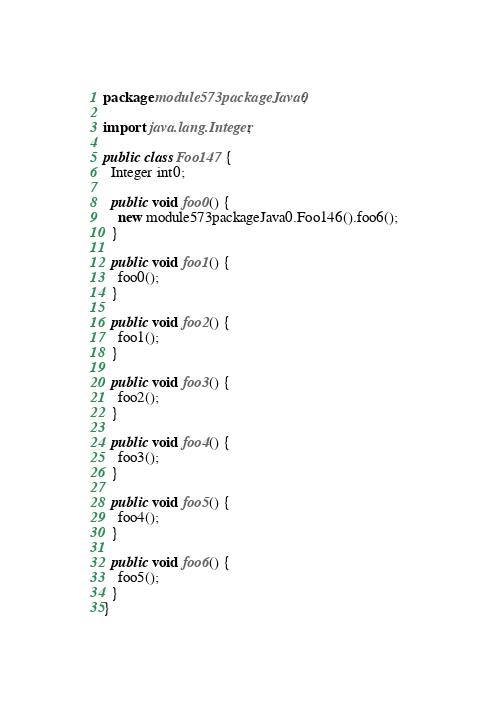Convert code to text. <code><loc_0><loc_0><loc_500><loc_500><_Java_>package module573packageJava0;

import java.lang.Integer;

public class Foo147 {
  Integer int0;

  public void foo0() {
    new module573packageJava0.Foo146().foo6();
  }

  public void foo1() {
    foo0();
  }

  public void foo2() {
    foo1();
  }

  public void foo3() {
    foo2();
  }

  public void foo4() {
    foo3();
  }

  public void foo5() {
    foo4();
  }

  public void foo6() {
    foo5();
  }
}
</code> 